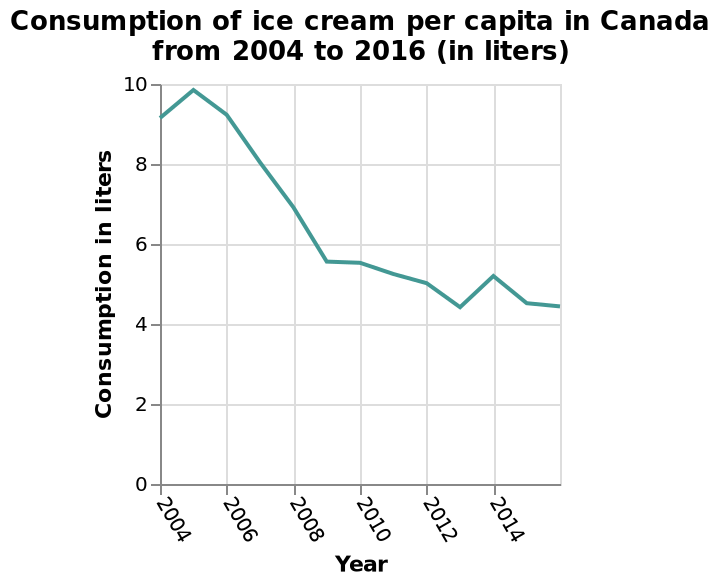<image>
What is the trend in the Canadian desire for ice cream?  The trend in the Canadian desire for ice cream is declining but stabilizing at around 50% of its starting figure. 